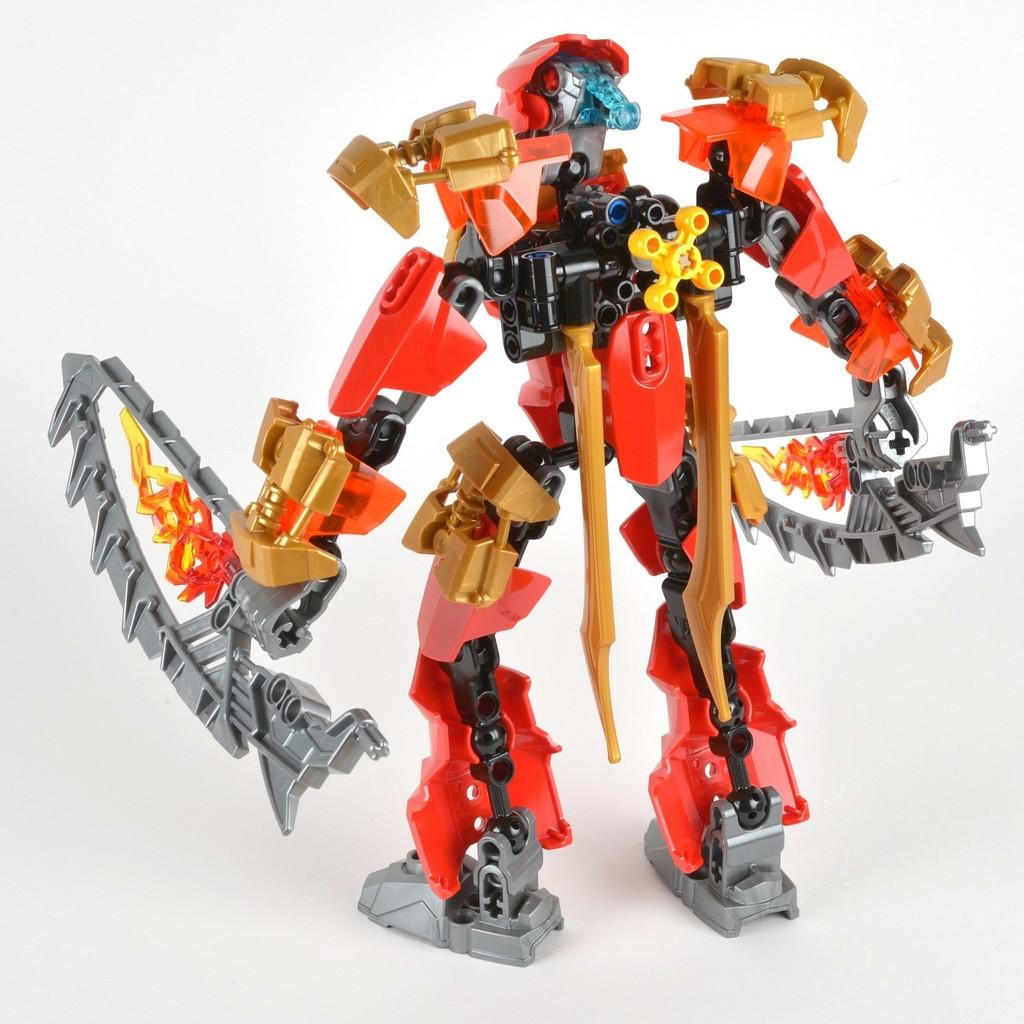What is the main subject of the image? There is a robot toy in the image. What color is the background of the image? The background of the image is white. What type of meal is the dad preparing for the maid in the image? There is no dad, maid, or meal present in the image; it only features a robot toy against a white background. 